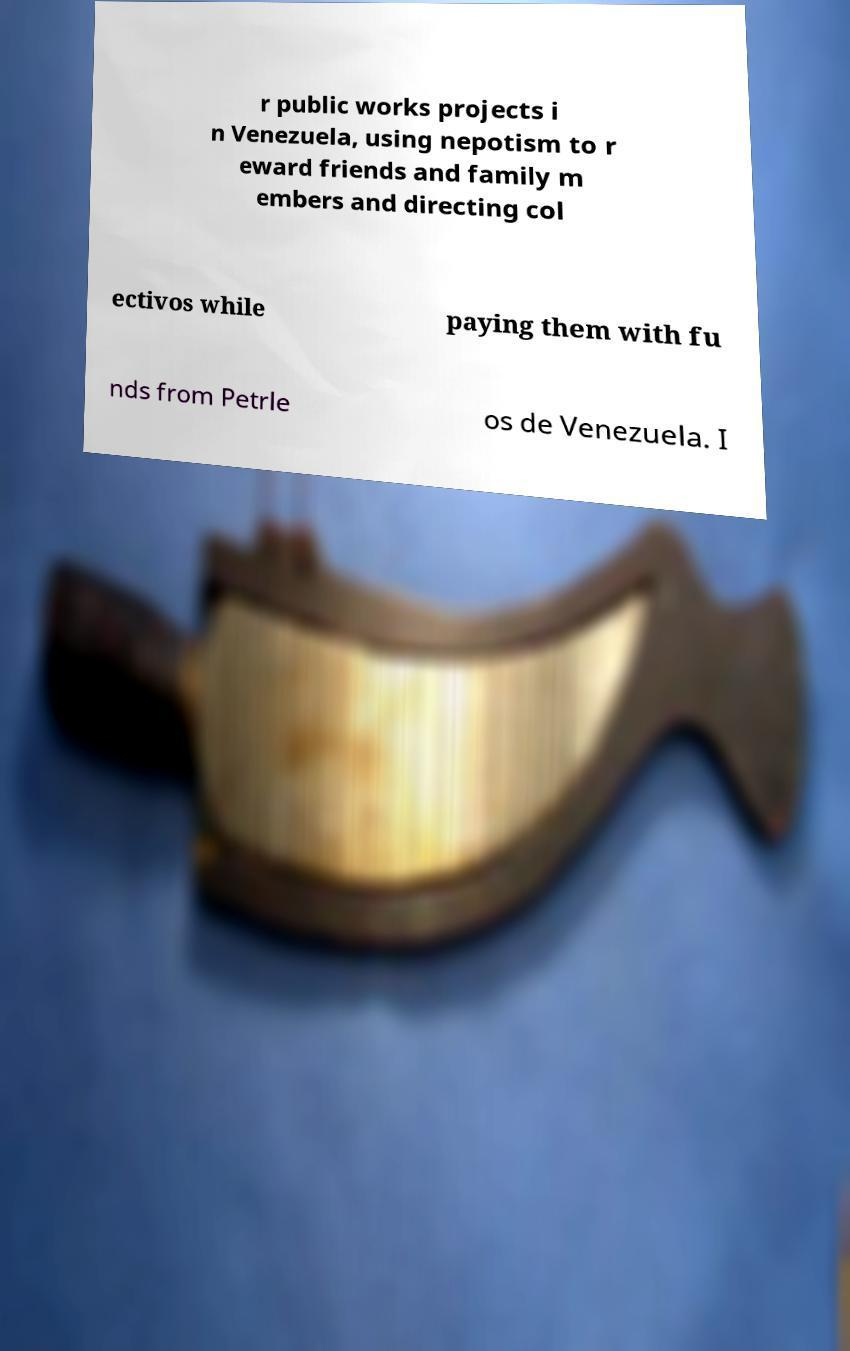Could you extract and type out the text from this image? r public works projects i n Venezuela, using nepotism to r eward friends and family m embers and directing col ectivos while paying them with fu nds from Petrle os de Venezuela. I 